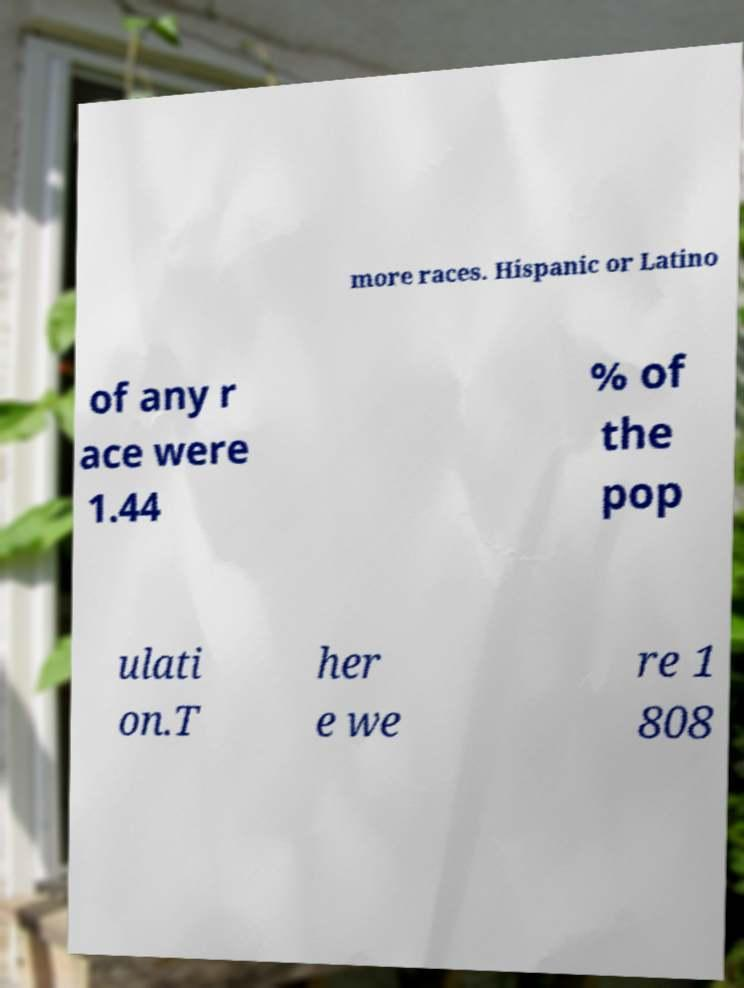What messages or text are displayed in this image? I need them in a readable, typed format. more races. Hispanic or Latino of any r ace were 1.44 % of the pop ulati on.T her e we re 1 808 